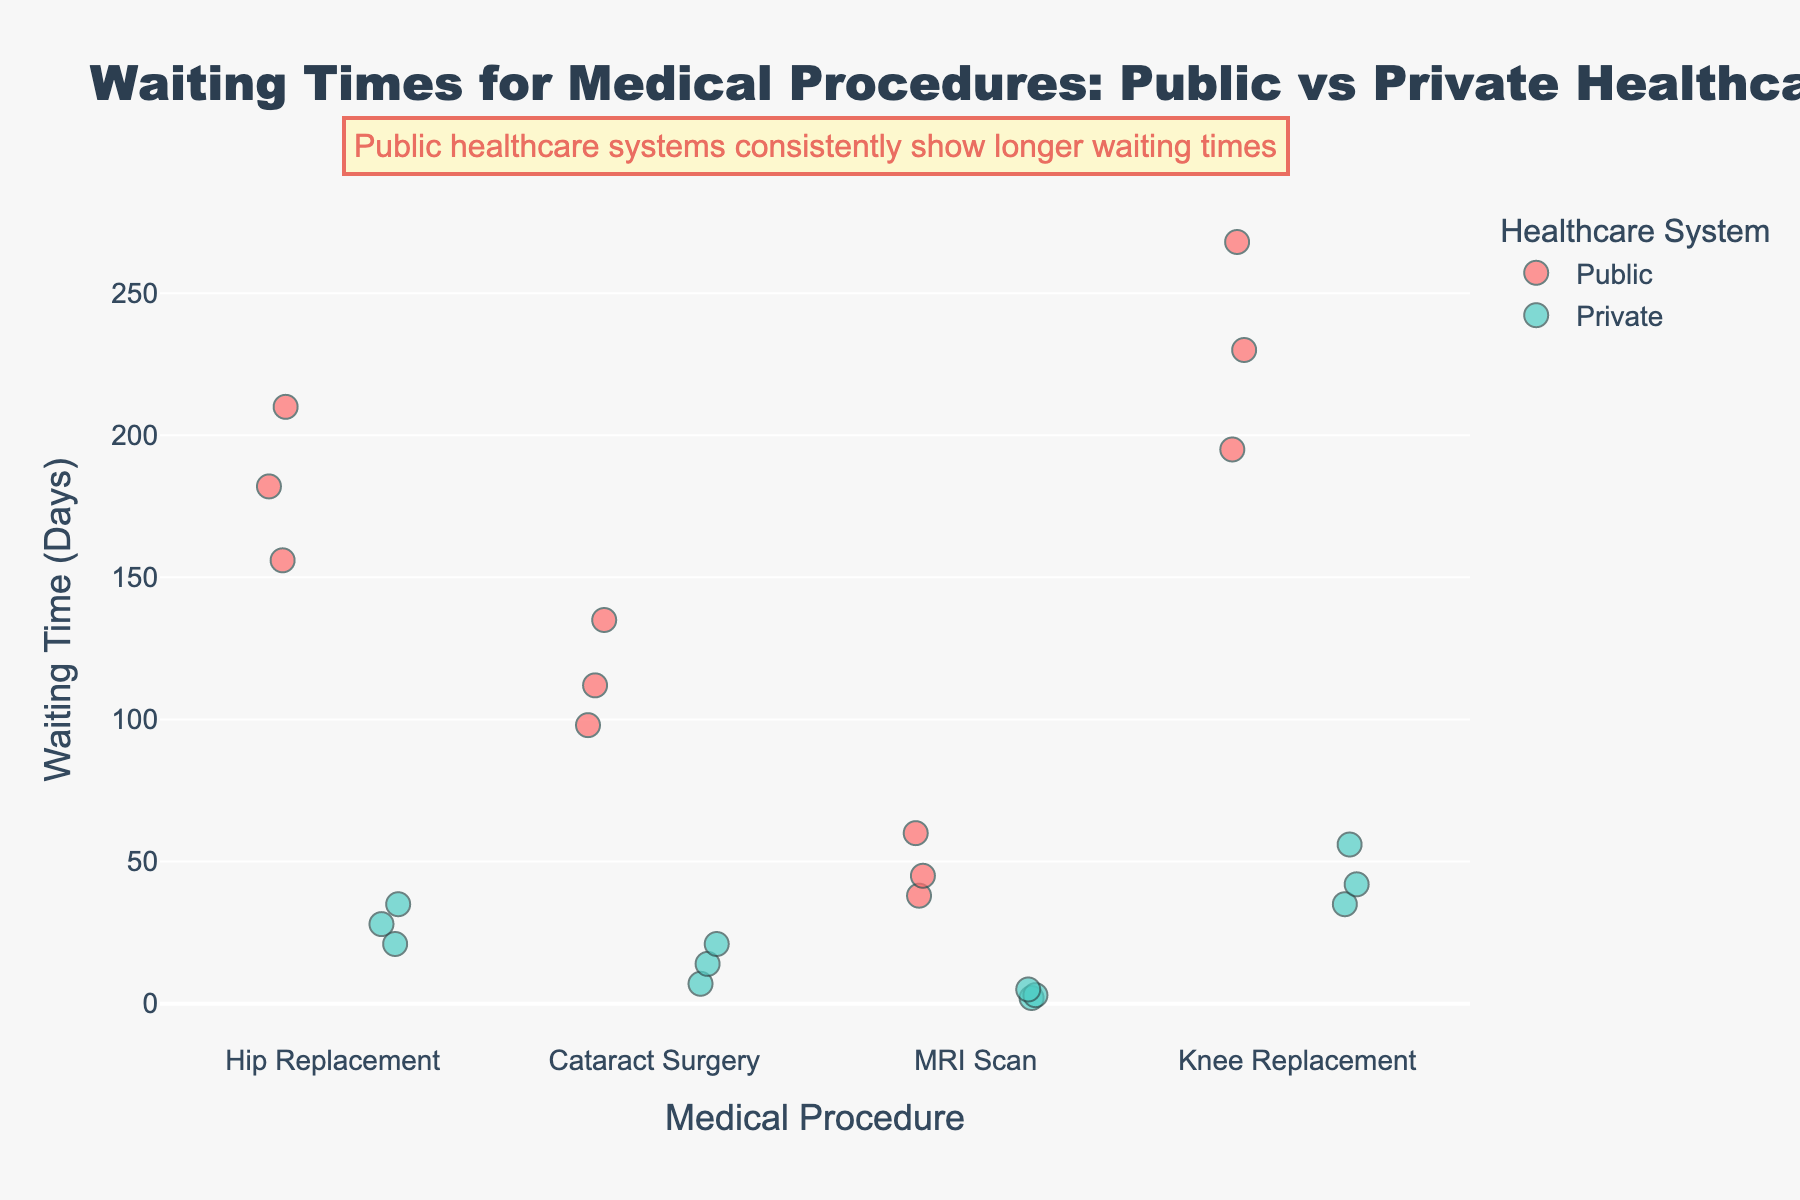What is the title of the plot? The title is the text usually found at the top of the figure, and it summarizes what the figure is about.
Answer: Waiting Times for Medical Procedures: Public vs Private Healthcare What are the two healthcare systems compared in the plot? The healthcare systems are indicated by the colors in the plot and are also labeled in the legend.
Answer: Public and Private Which medical procedure has the longest waiting time in the public healthcare system? By examining the points along the vertical axis labeled "Waiting Time (Days)", look for the highest value for the "Public" system.
Answer: Knee Replacement What color represents the public healthcare system in the plot? The legend indicates the color associated with each system.
Answer: Red For the MRI Scan procedure, by how many days does the average waiting time in the public system exceed the private system? Find the average waiting time for the MRI Scan procedure in both systems, then subtract the private system's average from the public system's average.
Answer: (45 + 60 + 38) / 3 - (3 + 5 + 2) / 3 = 47 days Which medical procedure has the smallest difference in waiting times between the public and private healthcare systems? Compare the waiting times for each pair of medical procedures between the two systems and find the one with the least difference.
Answer: MRI Scan Are the waiting times generally longer in the public healthcare system compared to the private healthcare system? Compare the overall trends and positions of the data points for both systems across all procedures.
Answer: Yes How many data points are there for each medical procedure in each healthcare system? Count the number of individual dots present for each procedure for both systems.
Answer: 3 data points For Cataract Surgery, what is the range of waiting times in the public system? Find the highest and lowest waiting times for Cataract Surgery in the public system and subtract the lowest from the highest.
Answer: 135 - 98 = 37 days What is the average waiting time for Hip Replacement in the private healthcare system? Add the waiting times for Hip Replacement in the private system and divide by the number of data points.
Answer: (28 + 35 + 21) / 3 = 28 days 